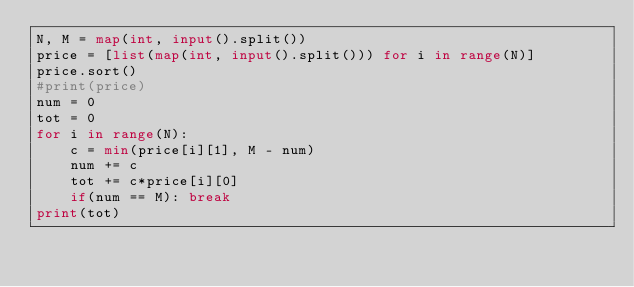Convert code to text. <code><loc_0><loc_0><loc_500><loc_500><_Python_>N, M = map(int, input().split())
price = [list(map(int, input().split())) for i in range(N)]
price.sort()
#print(price)
num = 0
tot = 0
for i in range(N):
    c = min(price[i][1], M - num)
    num += c
    tot += c*price[i][0]
    if(num == M): break
print(tot)</code> 